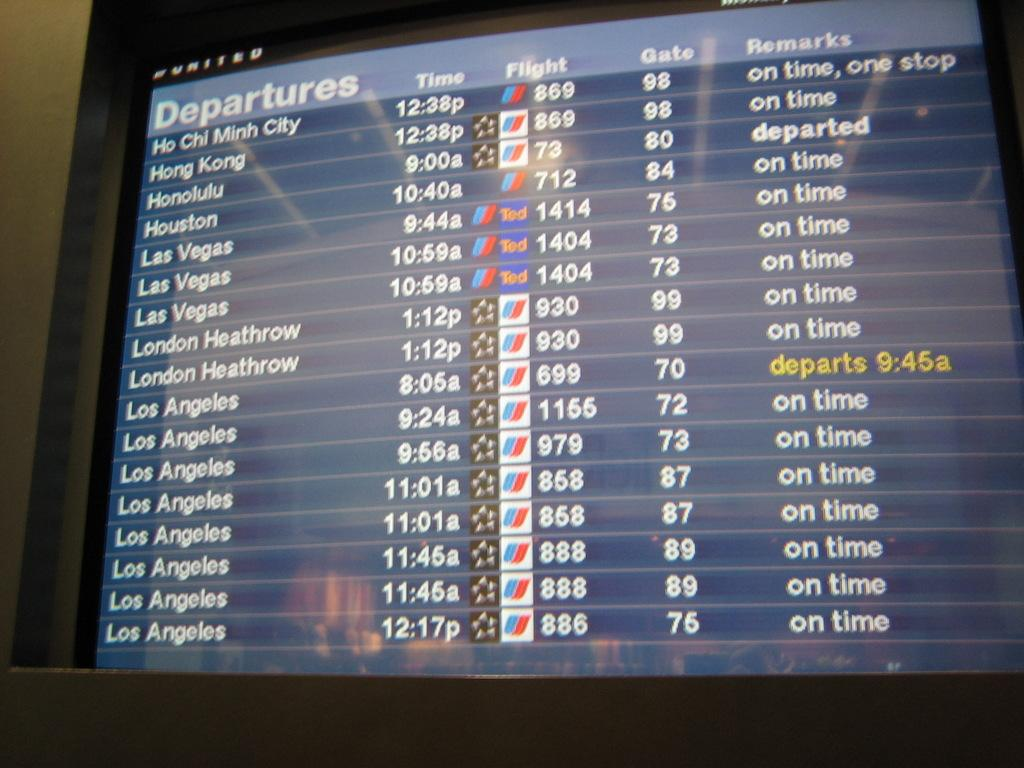Provide a one-sentence caption for the provided image. a computer screen with the flight departures via Hong Kong, Las Vegas, Los Angeles, and others. 